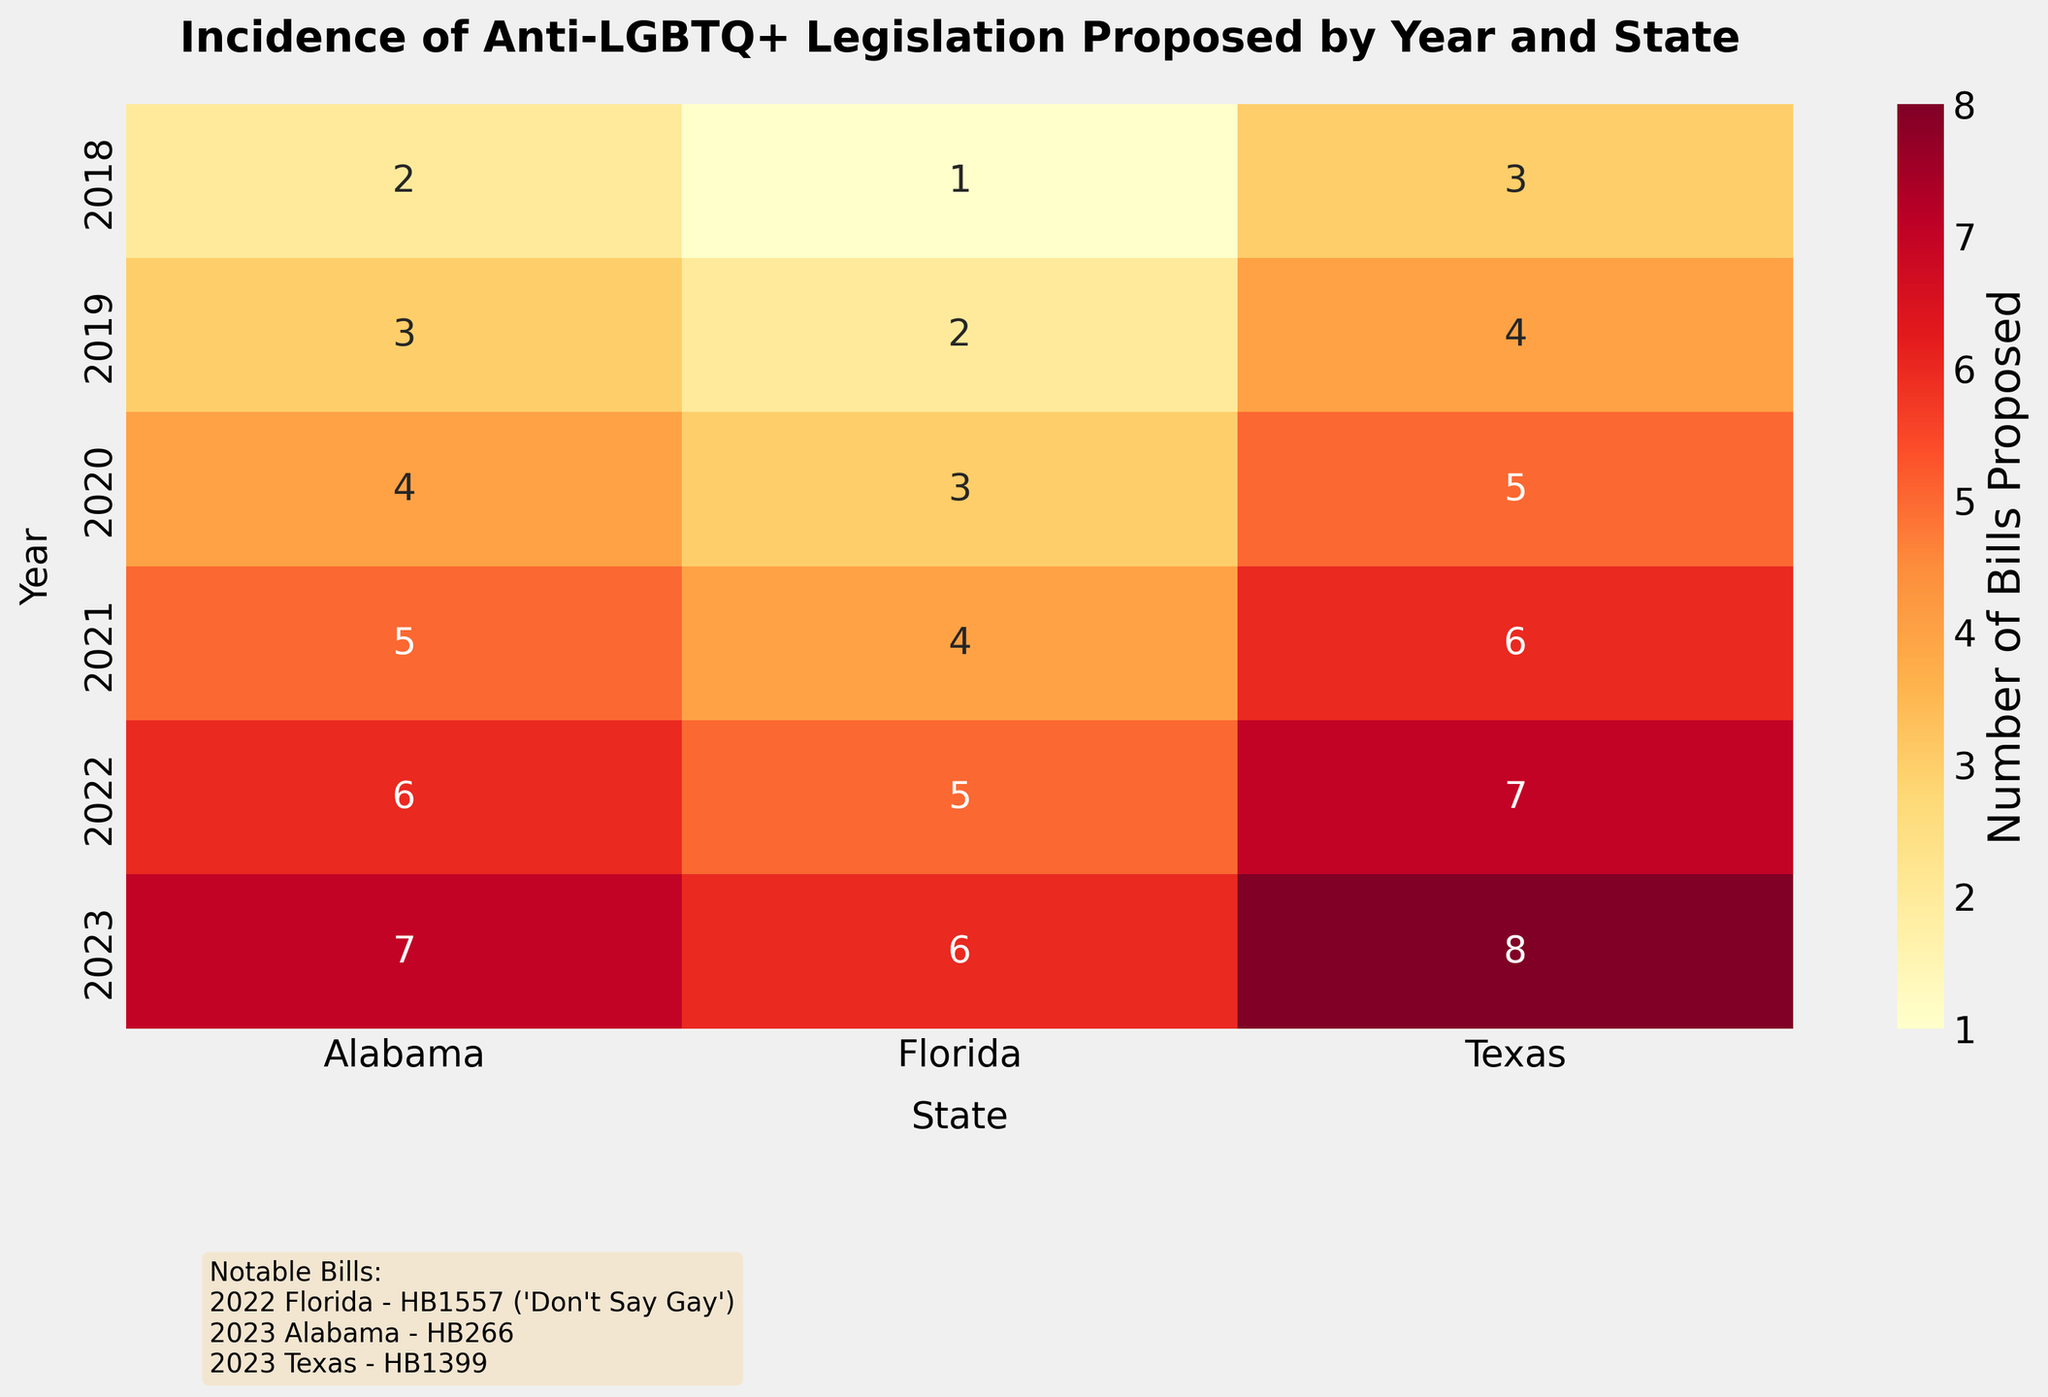What's the title of the heatmap? The title of the heatmap is located at the top of the figure, providing information about what the plot represents.
Answer: Incidence of Anti-LGBTQ+ Legislation Proposed by Year and State Which state proposed the highest number of anti-LGBTQ+ bills in 2023? Look at the data in the heatmap for the year 2023 and compare the values for each state. Texas has the highest number (8) of bills proposed in 2023.
Answer: Texas How many bills were proposed in Alabama in the year 2021? Find the row corresponding to the year 2021 and then locate the column for Alabama. The heatmap shows that 5 bills were proposed.
Answer: 5 Compare the number of bills proposed in Florida between 2020 and 2022. Which year had more bills proposed? Look at the heatmap and find the values for Florida in 2020 and 2022. In 2020, 3 bills were proposed, while in 2022, 5 bills were proposed. Hence, 2022 had more bills.
Answer: 2022 What can you say about the trend of anti-LGBTQ+ bills in Alabama from 2018 to 2023? Locate the values for Alabama across the years from 2018 to 2023. The trend shows an increasing number of bills: 2 (2018), 3 (2019), 4 (2020), 5 (2021), 6 (2022), 7 (2023). The number of bills proposed has been increasing each year.
Answer: Increasing trend Which notable bill is mentioned in the information text box for Florida in 2022? The text box at the bottom of the heatmap indicates notable bills. For Florida in 2022, the notable bill mentioned is "HB1557", also known as the "Don't Say Gay" bill.
Answer: HB1557 Compare the total number of bills proposed in 2018 and 2023. Which year had a higher count, and by how much? Sum the number of bills proposed across all states for each year. In 2018: 2 (AL) + 3 (TX) + 1 (FL) = 6. In 2023: 7 (AL) + 8 (TX) + 6 (FL) = 21. 2023 had a higher count by 15 bills (21 - 6 = 15).
Answer: 2023 by 15 How many states are represented in the heatmap? The states are listed on the x-axis of the heatmap. There are three states: Alabama, Texas, and Florida.
Answer: 3 Which year had the lowest total number of bills proposed across all states, and what was the total? Sum the number of bills proposed for each year and compare. 2018: 6, 2019: 9, 2020: 12, 2021: 15, 2022: 18, 2023: 21. The year with the lowest total is 2018 with 6 bills.
Answer: 2018 with 6 bills 